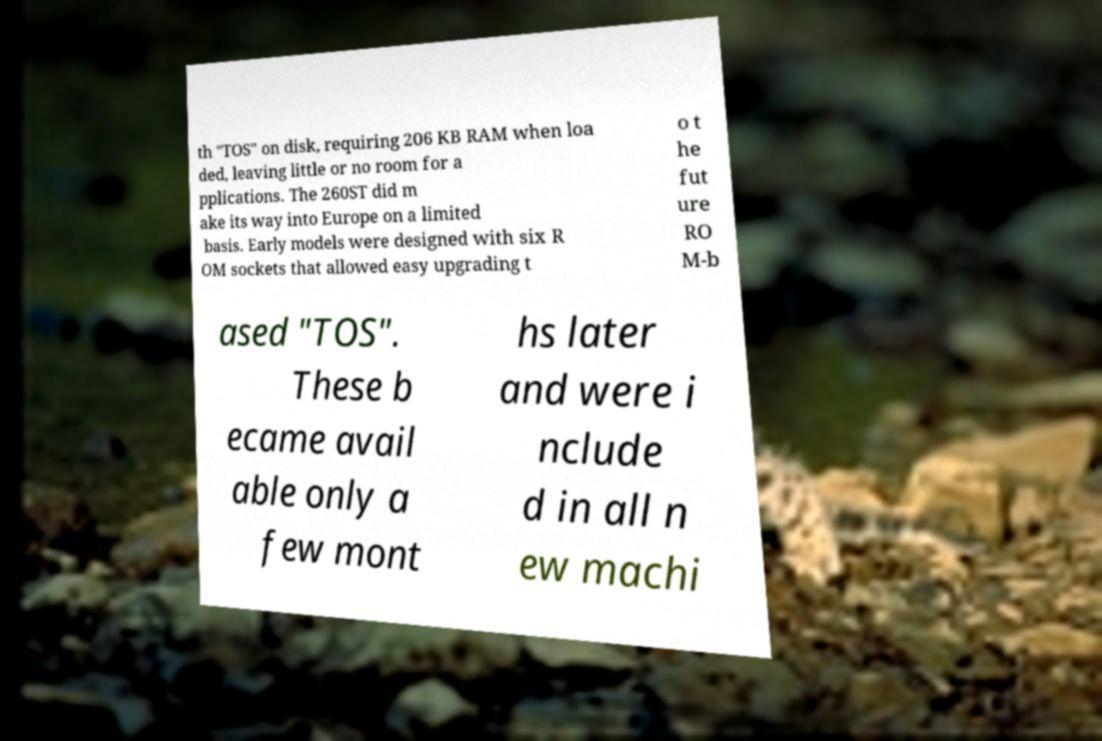Could you assist in decoding the text presented in this image and type it out clearly? th "TOS" on disk, requiring 206 KB RAM when loa ded, leaving little or no room for a pplications. The 260ST did m ake its way into Europe on a limited basis. Early models were designed with six R OM sockets that allowed easy upgrading t o t he fut ure RO M-b ased "TOS". These b ecame avail able only a few mont hs later and were i nclude d in all n ew machi 